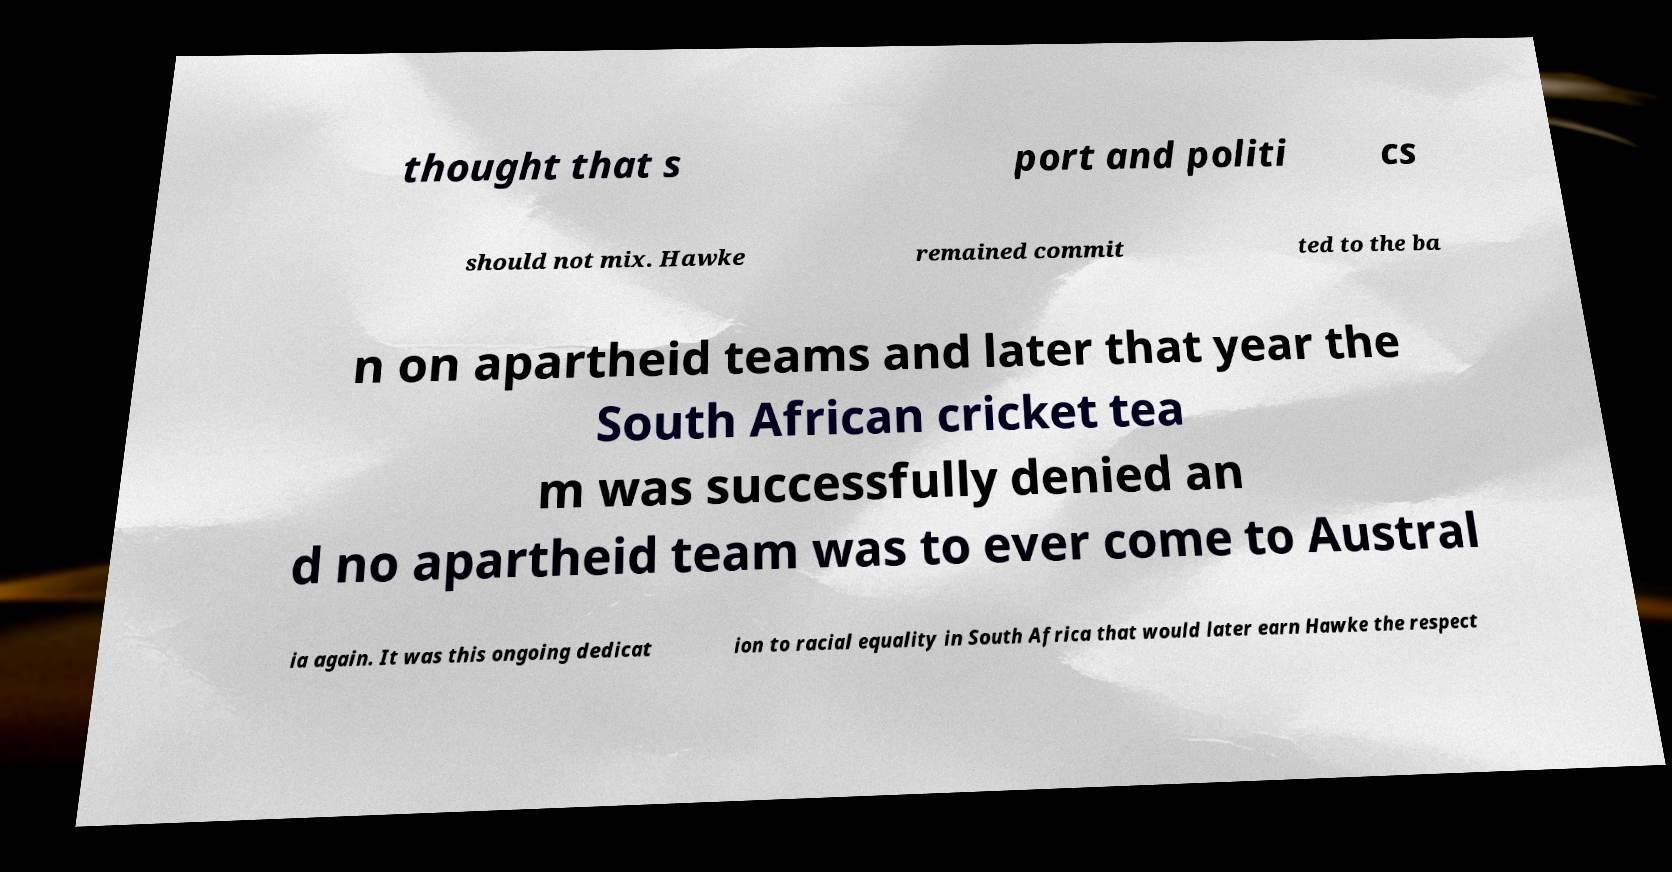I need the written content from this picture converted into text. Can you do that? thought that s port and politi cs should not mix. Hawke remained commit ted to the ba n on apartheid teams and later that year the South African cricket tea m was successfully denied an d no apartheid team was to ever come to Austral ia again. It was this ongoing dedicat ion to racial equality in South Africa that would later earn Hawke the respect 